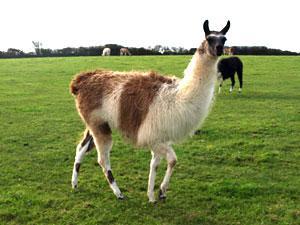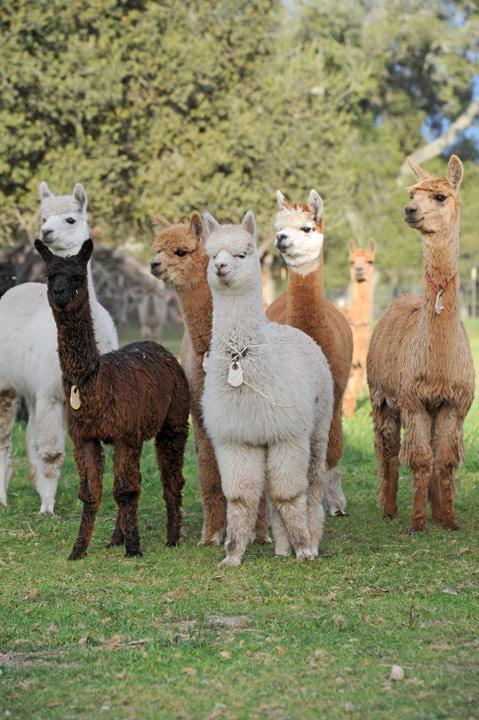The first image is the image on the left, the second image is the image on the right. For the images shown, is this caption "There is exactly one llama in the left image." true? Answer yes or no. No. 